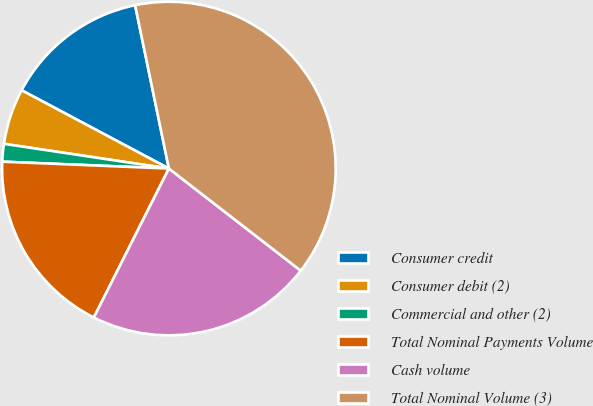<chart> <loc_0><loc_0><loc_500><loc_500><pie_chart><fcel>Consumer credit<fcel>Consumer debit (2)<fcel>Commercial and other (2)<fcel>Total Nominal Payments Volume<fcel>Cash volume<fcel>Total Nominal Volume (3)<nl><fcel>13.98%<fcel>5.41%<fcel>1.71%<fcel>18.23%<fcel>21.94%<fcel>38.74%<nl></chart> 